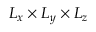Convert formula to latex. <formula><loc_0><loc_0><loc_500><loc_500>L _ { x } L _ { y } L _ { z }</formula> 